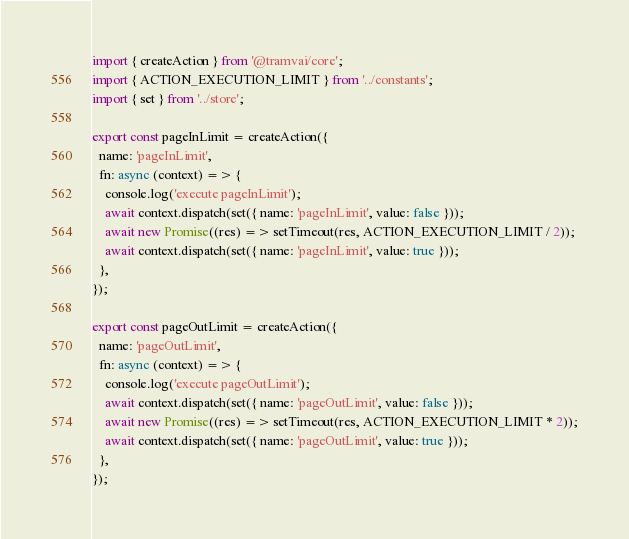<code> <loc_0><loc_0><loc_500><loc_500><_TypeScript_>import { createAction } from '@tramvai/core';
import { ACTION_EXECUTION_LIMIT } from '../constants';
import { set } from '../store';

export const pageInLimit = createAction({
  name: 'pageInLimit',
  fn: async (context) => {
    console.log('execute pageInLimit');
    await context.dispatch(set({ name: 'pageInLimit', value: false }));
    await new Promise((res) => setTimeout(res, ACTION_EXECUTION_LIMIT / 2));
    await context.dispatch(set({ name: 'pageInLimit', value: true }));
  },
});

export const pageOutLimit = createAction({
  name: 'pageOutLimit',
  fn: async (context) => {
    console.log('execute pageOutLimit');
    await context.dispatch(set({ name: 'pageOutLimit', value: false }));
    await new Promise((res) => setTimeout(res, ACTION_EXECUTION_LIMIT * 2));
    await context.dispatch(set({ name: 'pageOutLimit', value: true }));
  },
});
</code> 